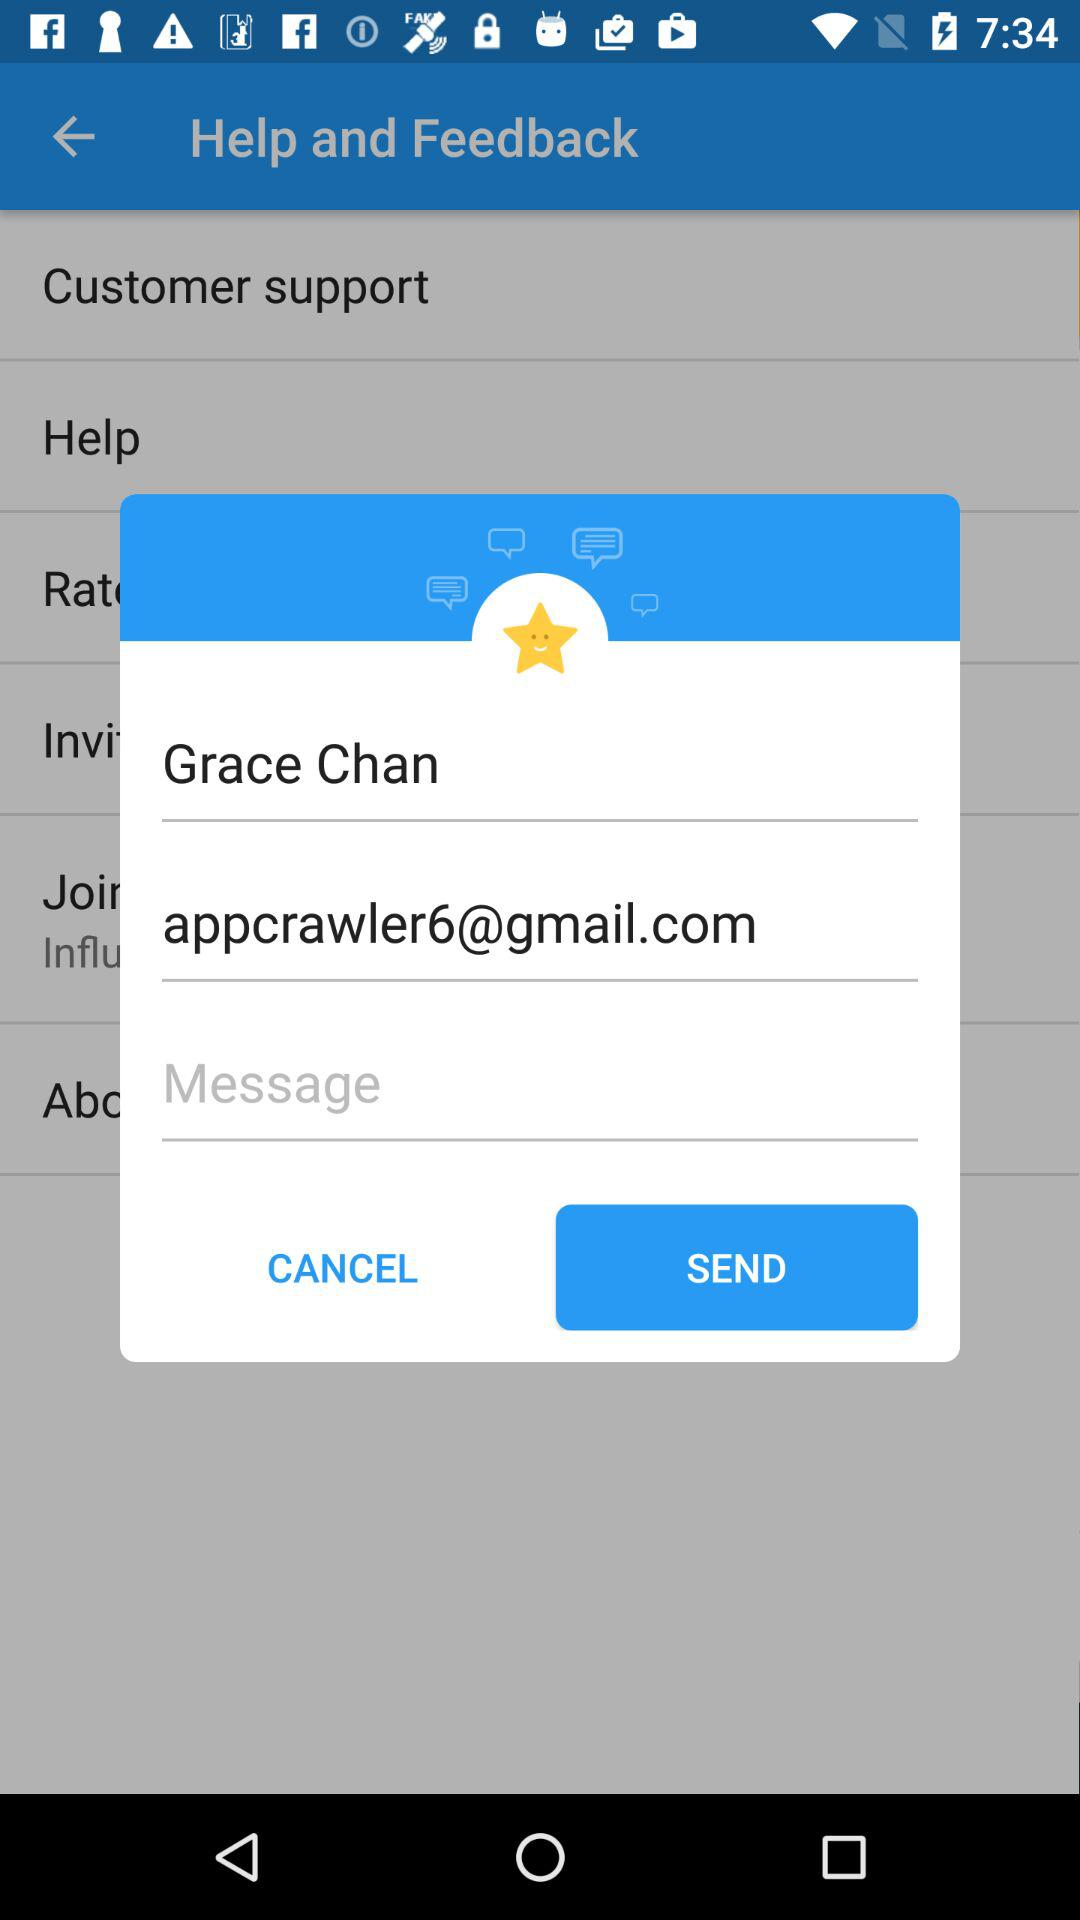What is the email address? The email address is appcrawler6@gmail.com. 